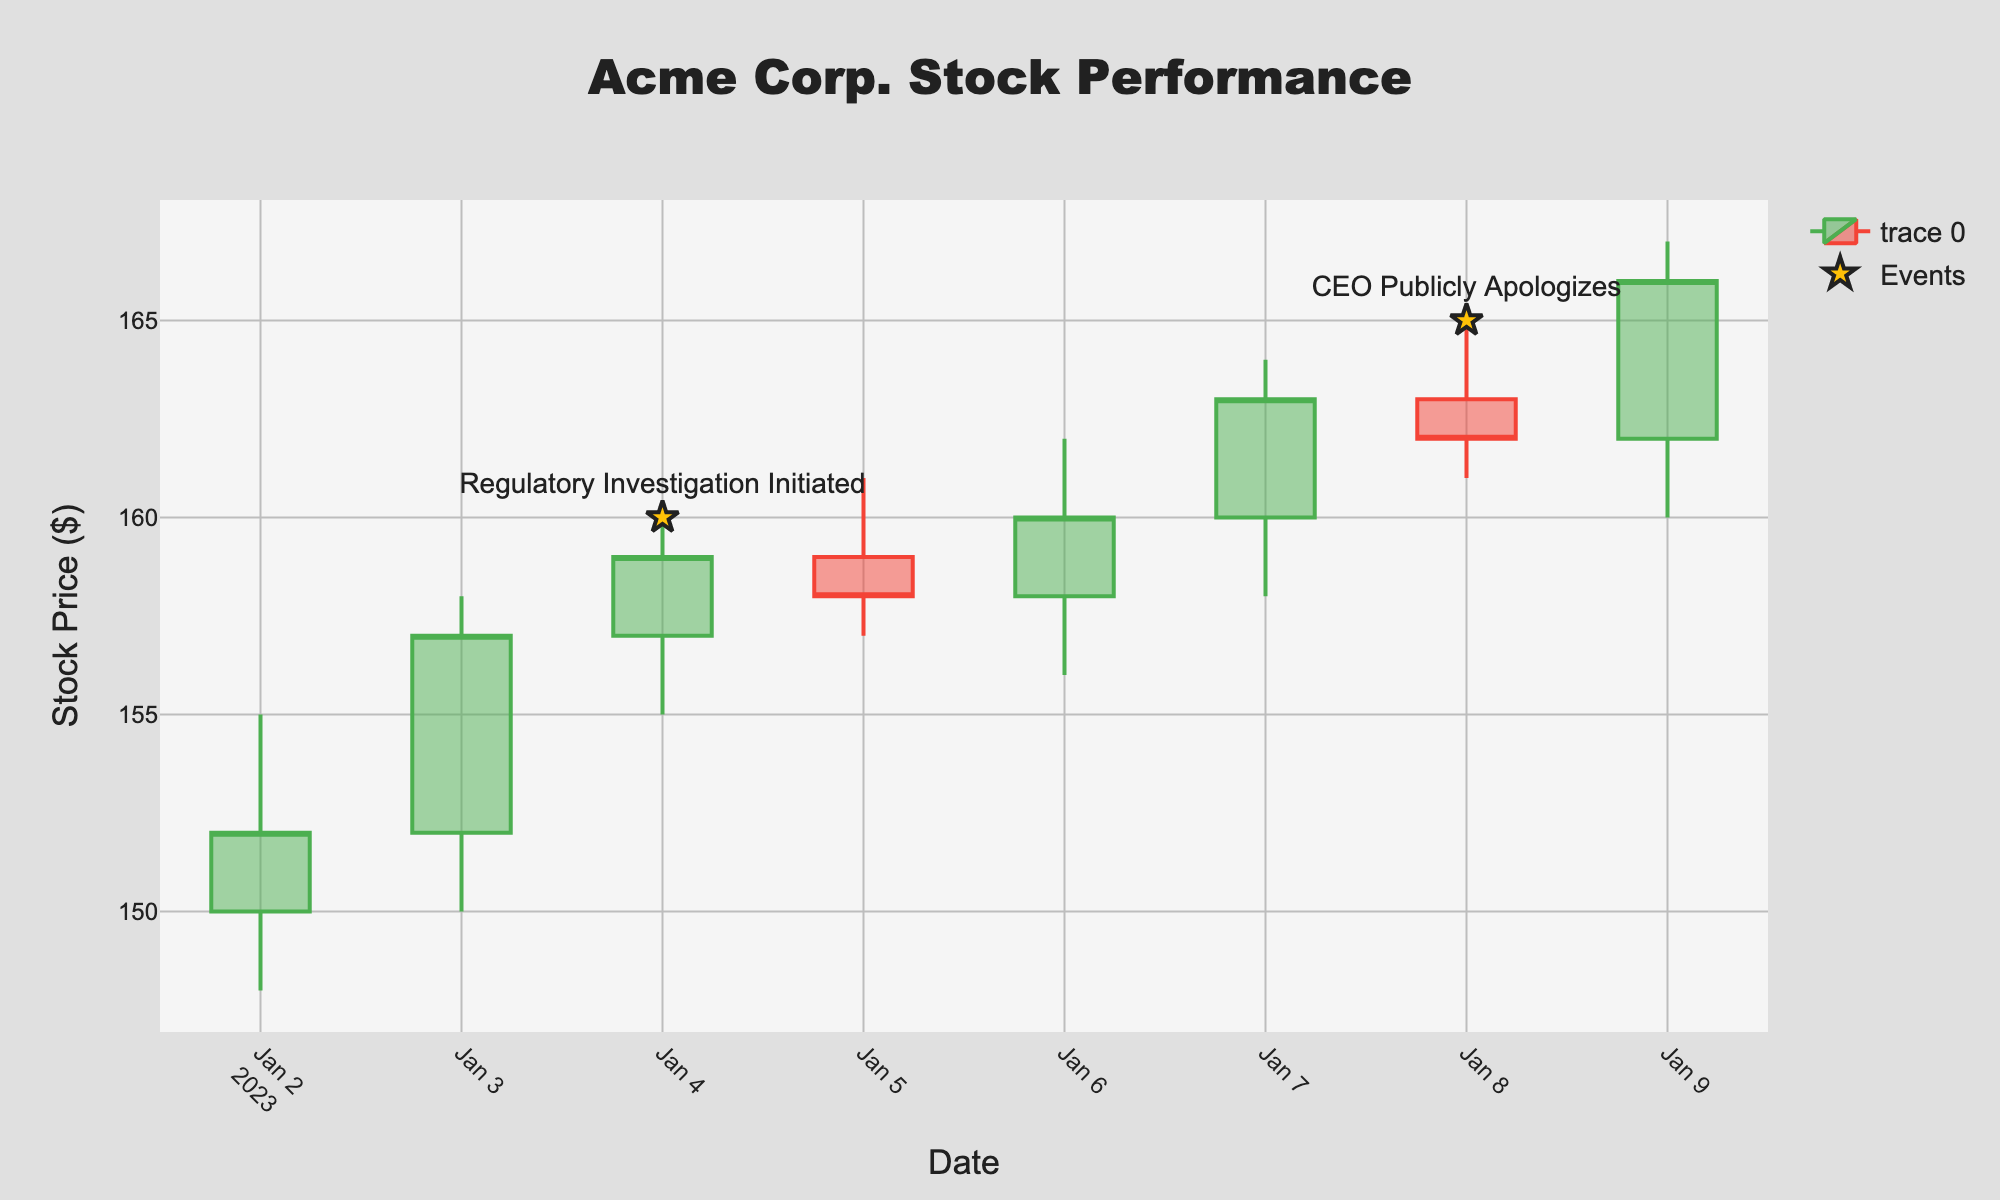What is the title of the plot? The title is usually placed at the top center of the figure. It summarizes the content of the plot. Here, we see the title as 'Acme Corp. Stock Performance'.
Answer: Acme Corp. Stock Performance What are the dates on which special events occurred? Special events in the plot are marked with star symbols and labeled with text. Observing these markers, we see events on '2023-01-04' and '2023-01-08'.
Answer: 2023-01-04 and 2023-01-08 How does the stock price change immediately after the regulatory investigation initiated compared to the day before? Specifically, under "Regulatory Investigation Initiated" (2023-01-04), the stock closed at 159. The day before, on (2023-01-03), it closed at 157. Hence, there's an increase from 157 to 159.
Answer: Increase from 157 to 159 What is the overall trend in stock prices two days after the CEO's public apology? Observing the plot, after the event on '2023-01-08' when the CEO publicly apologized, the stock closed at 162. On '2023-01-09', it closed at 166. The trend, therefore, shows an increase.
Answer: It increased Which day had the highest trading volume, and what was that volume? The volume of trades can be read from the Volumes data. The highest volume of 1,600,000 trades occurred on '2023-01-09'.
Answer: 2023-01-09 with a volume of 1,600,000 How does the stock performance on the day of CEO's public apology compare to the previous day? On '2023-01-08', the CEO apologized, closing at 162. The previous day, '2023-01-07', it closed at 163. Thus, the stock price decreased from 163 to 162.
Answer: Decreased from 163 to 162 What was the lowest recorded stock price during the week, and on which date did it occur? The lowest price is indicated in the 'Low' section of the data. The lowest was 148 on '2023-01-02'.
Answer: 148 on 2023-01-02 Which day experienced the largest difference between high and low prices? Calculate the differences (High - Low) for each day. '2023-01-09' has the highest difference of 7 (167 - 160).
Answer: 2023-01-09 How many days after the regulatory investigation did the CEO publicly apologize? Look at the dates: 'Regulatory Investigation Initiated' on '2023-01-04' and 'CEO Publicly Apologizes' on '2023-01-08'. The difference is 4 days.
Answer: 4 days 